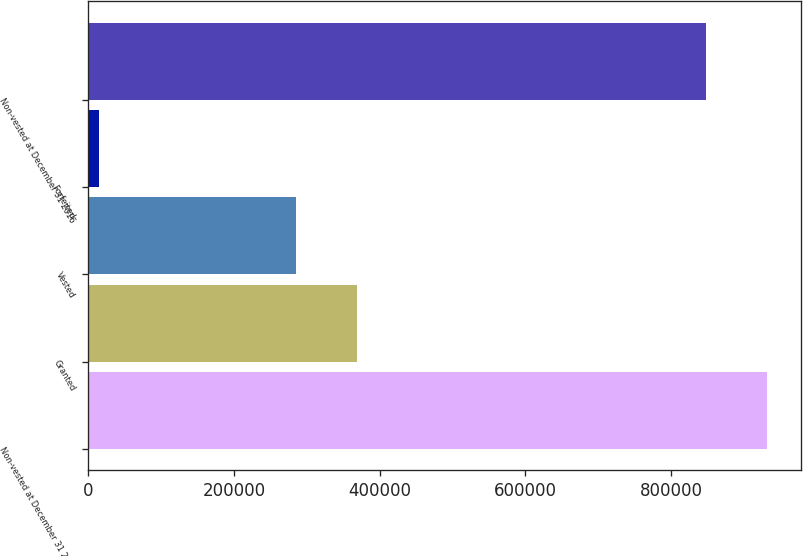<chart> <loc_0><loc_0><loc_500><loc_500><bar_chart><fcel>Non-vested at December 31 2015<fcel>Granted<fcel>Vested<fcel>Forfeited<fcel>Non-vested at December 31 2016<nl><fcel>932162<fcel>368982<fcel>285162<fcel>15053<fcel>848342<nl></chart> 